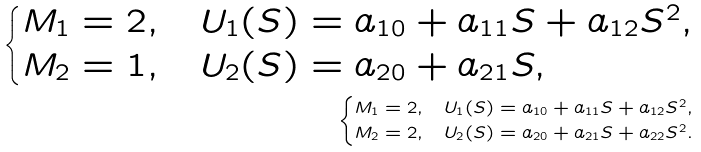<formula> <loc_0><loc_0><loc_500><loc_500>\begin{cases} M _ { 1 } = 2 , & U _ { 1 } ( S ) = a _ { 1 0 } + a _ { 1 1 } S + a _ { 1 2 } S ^ { 2 } , \\ M _ { 2 } = 1 , & U _ { 2 } ( S ) = a _ { 2 0 } + a _ { 2 1 } S , \end{cases} \\ \begin{cases} M _ { 1 } = 2 , & U _ { 1 } ( S ) = a _ { 1 0 } + a _ { 1 1 } S + a _ { 1 2 } S ^ { 2 } , \\ M _ { 2 } = 2 , & U _ { 2 } ( S ) = a _ { 2 0 } + a _ { 2 1 } S + a _ { 2 2 } S ^ { 2 } . \end{cases}</formula> 